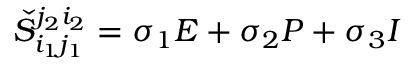<formula> <loc_0><loc_0><loc_500><loc_500>\check { S } _ { i _ { 1 } j _ { 1 } } ^ { j _ { 2 } i _ { 2 } } = \sigma _ { 1 } E + \sigma _ { 2 } P + \sigma _ { 3 } I</formula> 